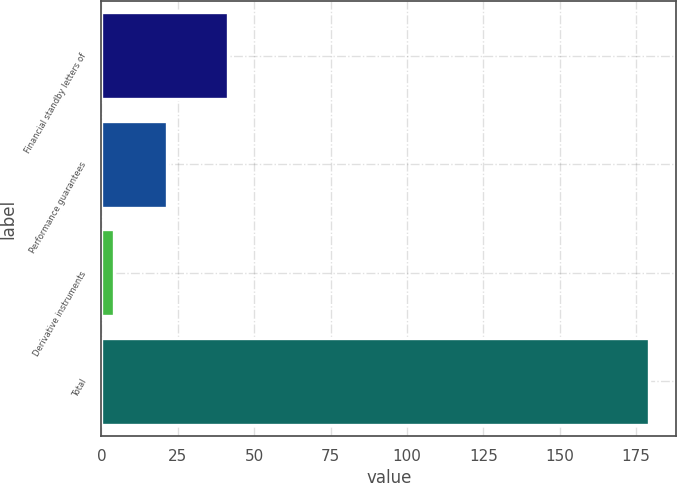Convert chart. <chart><loc_0><loc_0><loc_500><loc_500><bar_chart><fcel>Financial standby letters of<fcel>Performance guarantees<fcel>Derivative instruments<fcel>Total<nl><fcel>41.4<fcel>21.6<fcel>4.1<fcel>179.1<nl></chart> 